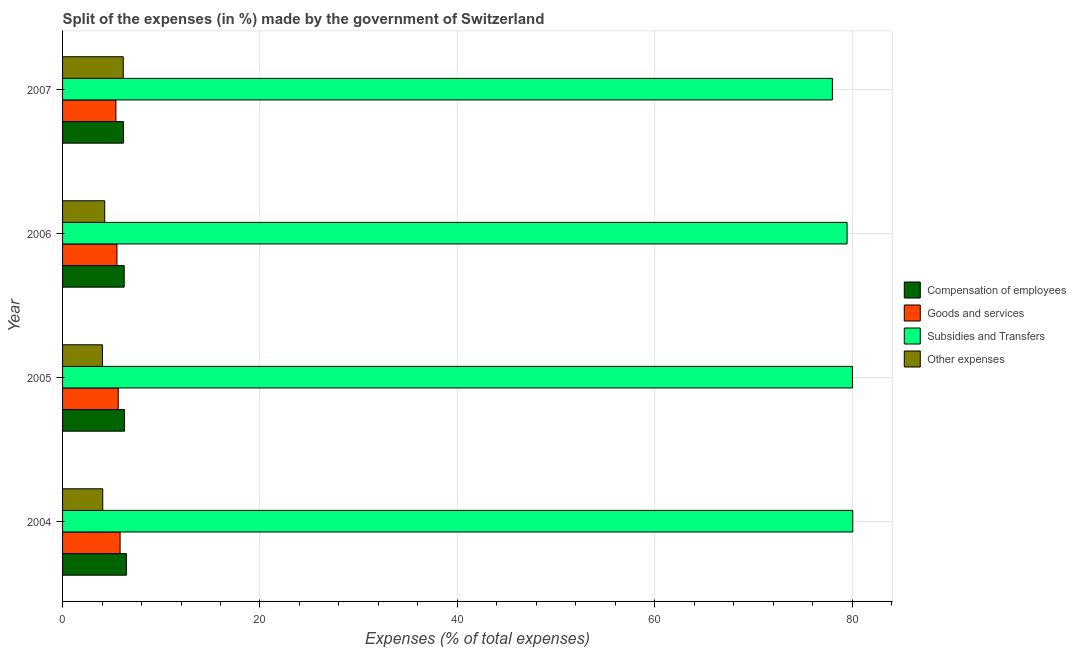How many different coloured bars are there?
Provide a succinct answer. 4. How many groups of bars are there?
Give a very brief answer. 4. Are the number of bars per tick equal to the number of legend labels?
Offer a terse response. Yes. Are the number of bars on each tick of the Y-axis equal?
Ensure brevity in your answer.  Yes. How many bars are there on the 3rd tick from the top?
Offer a terse response. 4. How many bars are there on the 2nd tick from the bottom?
Your answer should be compact. 4. What is the percentage of amount spent on subsidies in 2007?
Your response must be concise. 77.99. Across all years, what is the maximum percentage of amount spent on subsidies?
Ensure brevity in your answer.  80.05. Across all years, what is the minimum percentage of amount spent on subsidies?
Provide a short and direct response. 77.99. In which year was the percentage of amount spent on other expenses maximum?
Ensure brevity in your answer.  2007. What is the total percentage of amount spent on goods and services in the graph?
Make the answer very short. 22.38. What is the difference between the percentage of amount spent on compensation of employees in 2005 and that in 2006?
Your response must be concise. 0.03. What is the difference between the percentage of amount spent on goods and services in 2004 and the percentage of amount spent on compensation of employees in 2005?
Offer a very short reply. -0.45. What is the average percentage of amount spent on subsidies per year?
Your answer should be compact. 79.38. In the year 2006, what is the difference between the percentage of amount spent on compensation of employees and percentage of amount spent on subsidies?
Your answer should be very brief. -73.23. What is the ratio of the percentage of amount spent on goods and services in 2004 to that in 2005?
Your answer should be compact. 1.03. What is the difference between the highest and the second highest percentage of amount spent on goods and services?
Make the answer very short. 0.19. In how many years, is the percentage of amount spent on goods and services greater than the average percentage of amount spent on goods and services taken over all years?
Provide a succinct answer. 2. Is the sum of the percentage of amount spent on subsidies in 2004 and 2006 greater than the maximum percentage of amount spent on other expenses across all years?
Your answer should be compact. Yes. Is it the case that in every year, the sum of the percentage of amount spent on compensation of employees and percentage of amount spent on goods and services is greater than the sum of percentage of amount spent on other expenses and percentage of amount spent on subsidies?
Make the answer very short. No. What does the 3rd bar from the top in 2004 represents?
Give a very brief answer. Goods and services. What does the 3rd bar from the bottom in 2006 represents?
Your response must be concise. Subsidies and Transfers. Is it the case that in every year, the sum of the percentage of amount spent on compensation of employees and percentage of amount spent on goods and services is greater than the percentage of amount spent on subsidies?
Ensure brevity in your answer.  No. How many bars are there?
Keep it short and to the point. 16. Are all the bars in the graph horizontal?
Your response must be concise. Yes. What is the difference between two consecutive major ticks on the X-axis?
Offer a very short reply. 20. Are the values on the major ticks of X-axis written in scientific E-notation?
Ensure brevity in your answer.  No. What is the title of the graph?
Provide a succinct answer. Split of the expenses (in %) made by the government of Switzerland. Does "Denmark" appear as one of the legend labels in the graph?
Offer a very short reply. No. What is the label or title of the X-axis?
Offer a very short reply. Expenses (% of total expenses). What is the Expenses (% of total expenses) in Compensation of employees in 2004?
Offer a terse response. 6.47. What is the Expenses (% of total expenses) in Goods and services in 2004?
Provide a short and direct response. 5.83. What is the Expenses (% of total expenses) of Subsidies and Transfers in 2004?
Make the answer very short. 80.05. What is the Expenses (% of total expenses) in Other expenses in 2004?
Give a very brief answer. 4.07. What is the Expenses (% of total expenses) of Compensation of employees in 2005?
Your answer should be very brief. 6.28. What is the Expenses (% of total expenses) of Goods and services in 2005?
Ensure brevity in your answer.  5.64. What is the Expenses (% of total expenses) in Subsidies and Transfers in 2005?
Keep it short and to the point. 80.02. What is the Expenses (% of total expenses) in Other expenses in 2005?
Offer a terse response. 4.04. What is the Expenses (% of total expenses) in Compensation of employees in 2006?
Keep it short and to the point. 6.24. What is the Expenses (% of total expenses) in Goods and services in 2006?
Your answer should be very brief. 5.51. What is the Expenses (% of total expenses) in Subsidies and Transfers in 2006?
Your answer should be compact. 79.48. What is the Expenses (% of total expenses) in Other expenses in 2006?
Your response must be concise. 4.27. What is the Expenses (% of total expenses) of Compensation of employees in 2007?
Provide a short and direct response. 6.17. What is the Expenses (% of total expenses) of Goods and services in 2007?
Provide a short and direct response. 5.4. What is the Expenses (% of total expenses) of Subsidies and Transfers in 2007?
Provide a succinct answer. 77.99. What is the Expenses (% of total expenses) in Other expenses in 2007?
Offer a terse response. 6.15. Across all years, what is the maximum Expenses (% of total expenses) of Compensation of employees?
Provide a short and direct response. 6.47. Across all years, what is the maximum Expenses (% of total expenses) of Goods and services?
Your answer should be very brief. 5.83. Across all years, what is the maximum Expenses (% of total expenses) in Subsidies and Transfers?
Provide a succinct answer. 80.05. Across all years, what is the maximum Expenses (% of total expenses) of Other expenses?
Offer a very short reply. 6.15. Across all years, what is the minimum Expenses (% of total expenses) of Compensation of employees?
Give a very brief answer. 6.17. Across all years, what is the minimum Expenses (% of total expenses) in Goods and services?
Your answer should be compact. 5.4. Across all years, what is the minimum Expenses (% of total expenses) in Subsidies and Transfers?
Make the answer very short. 77.99. Across all years, what is the minimum Expenses (% of total expenses) of Other expenses?
Keep it short and to the point. 4.04. What is the total Expenses (% of total expenses) in Compensation of employees in the graph?
Give a very brief answer. 25.15. What is the total Expenses (% of total expenses) in Goods and services in the graph?
Provide a succinct answer. 22.38. What is the total Expenses (% of total expenses) of Subsidies and Transfers in the graph?
Your answer should be very brief. 317.53. What is the total Expenses (% of total expenses) in Other expenses in the graph?
Your response must be concise. 18.53. What is the difference between the Expenses (% of total expenses) of Compensation of employees in 2004 and that in 2005?
Your response must be concise. 0.19. What is the difference between the Expenses (% of total expenses) in Goods and services in 2004 and that in 2005?
Your answer should be very brief. 0.19. What is the difference between the Expenses (% of total expenses) of Subsidies and Transfers in 2004 and that in 2005?
Ensure brevity in your answer.  0.03. What is the difference between the Expenses (% of total expenses) in Other expenses in 2004 and that in 2005?
Your response must be concise. 0.03. What is the difference between the Expenses (% of total expenses) in Compensation of employees in 2004 and that in 2006?
Your response must be concise. 0.22. What is the difference between the Expenses (% of total expenses) of Goods and services in 2004 and that in 2006?
Provide a succinct answer. 0.32. What is the difference between the Expenses (% of total expenses) of Subsidies and Transfers in 2004 and that in 2006?
Keep it short and to the point. 0.57. What is the difference between the Expenses (% of total expenses) of Other expenses in 2004 and that in 2006?
Your response must be concise. -0.2. What is the difference between the Expenses (% of total expenses) in Compensation of employees in 2004 and that in 2007?
Ensure brevity in your answer.  0.3. What is the difference between the Expenses (% of total expenses) of Goods and services in 2004 and that in 2007?
Provide a succinct answer. 0.43. What is the difference between the Expenses (% of total expenses) of Subsidies and Transfers in 2004 and that in 2007?
Give a very brief answer. 2.06. What is the difference between the Expenses (% of total expenses) in Other expenses in 2004 and that in 2007?
Make the answer very short. -2.08. What is the difference between the Expenses (% of total expenses) of Compensation of employees in 2005 and that in 2006?
Keep it short and to the point. 0.03. What is the difference between the Expenses (% of total expenses) of Goods and services in 2005 and that in 2006?
Keep it short and to the point. 0.13. What is the difference between the Expenses (% of total expenses) in Subsidies and Transfers in 2005 and that in 2006?
Offer a very short reply. 0.54. What is the difference between the Expenses (% of total expenses) in Other expenses in 2005 and that in 2006?
Provide a short and direct response. -0.23. What is the difference between the Expenses (% of total expenses) of Compensation of employees in 2005 and that in 2007?
Offer a terse response. 0.11. What is the difference between the Expenses (% of total expenses) of Goods and services in 2005 and that in 2007?
Offer a terse response. 0.23. What is the difference between the Expenses (% of total expenses) in Subsidies and Transfers in 2005 and that in 2007?
Your answer should be compact. 2.03. What is the difference between the Expenses (% of total expenses) of Other expenses in 2005 and that in 2007?
Provide a short and direct response. -2.11. What is the difference between the Expenses (% of total expenses) in Compensation of employees in 2006 and that in 2007?
Your response must be concise. 0.08. What is the difference between the Expenses (% of total expenses) in Goods and services in 2006 and that in 2007?
Provide a succinct answer. 0.11. What is the difference between the Expenses (% of total expenses) in Subsidies and Transfers in 2006 and that in 2007?
Your response must be concise. 1.49. What is the difference between the Expenses (% of total expenses) in Other expenses in 2006 and that in 2007?
Provide a short and direct response. -1.88. What is the difference between the Expenses (% of total expenses) in Compensation of employees in 2004 and the Expenses (% of total expenses) in Goods and services in 2005?
Provide a short and direct response. 0.83. What is the difference between the Expenses (% of total expenses) in Compensation of employees in 2004 and the Expenses (% of total expenses) in Subsidies and Transfers in 2005?
Offer a very short reply. -73.55. What is the difference between the Expenses (% of total expenses) of Compensation of employees in 2004 and the Expenses (% of total expenses) of Other expenses in 2005?
Provide a short and direct response. 2.43. What is the difference between the Expenses (% of total expenses) of Goods and services in 2004 and the Expenses (% of total expenses) of Subsidies and Transfers in 2005?
Offer a terse response. -74.19. What is the difference between the Expenses (% of total expenses) in Goods and services in 2004 and the Expenses (% of total expenses) in Other expenses in 2005?
Your response must be concise. 1.79. What is the difference between the Expenses (% of total expenses) in Subsidies and Transfers in 2004 and the Expenses (% of total expenses) in Other expenses in 2005?
Your response must be concise. 76.01. What is the difference between the Expenses (% of total expenses) of Compensation of employees in 2004 and the Expenses (% of total expenses) of Goods and services in 2006?
Your answer should be very brief. 0.96. What is the difference between the Expenses (% of total expenses) in Compensation of employees in 2004 and the Expenses (% of total expenses) in Subsidies and Transfers in 2006?
Provide a succinct answer. -73.01. What is the difference between the Expenses (% of total expenses) of Compensation of employees in 2004 and the Expenses (% of total expenses) of Other expenses in 2006?
Provide a succinct answer. 2.2. What is the difference between the Expenses (% of total expenses) in Goods and services in 2004 and the Expenses (% of total expenses) in Subsidies and Transfers in 2006?
Keep it short and to the point. -73.65. What is the difference between the Expenses (% of total expenses) of Goods and services in 2004 and the Expenses (% of total expenses) of Other expenses in 2006?
Your response must be concise. 1.56. What is the difference between the Expenses (% of total expenses) in Subsidies and Transfers in 2004 and the Expenses (% of total expenses) in Other expenses in 2006?
Keep it short and to the point. 75.78. What is the difference between the Expenses (% of total expenses) of Compensation of employees in 2004 and the Expenses (% of total expenses) of Goods and services in 2007?
Provide a succinct answer. 1.06. What is the difference between the Expenses (% of total expenses) in Compensation of employees in 2004 and the Expenses (% of total expenses) in Subsidies and Transfers in 2007?
Provide a short and direct response. -71.52. What is the difference between the Expenses (% of total expenses) in Compensation of employees in 2004 and the Expenses (% of total expenses) in Other expenses in 2007?
Make the answer very short. 0.32. What is the difference between the Expenses (% of total expenses) of Goods and services in 2004 and the Expenses (% of total expenses) of Subsidies and Transfers in 2007?
Give a very brief answer. -72.16. What is the difference between the Expenses (% of total expenses) in Goods and services in 2004 and the Expenses (% of total expenses) in Other expenses in 2007?
Ensure brevity in your answer.  -0.32. What is the difference between the Expenses (% of total expenses) in Subsidies and Transfers in 2004 and the Expenses (% of total expenses) in Other expenses in 2007?
Ensure brevity in your answer.  73.9. What is the difference between the Expenses (% of total expenses) in Compensation of employees in 2005 and the Expenses (% of total expenses) in Goods and services in 2006?
Provide a short and direct response. 0.77. What is the difference between the Expenses (% of total expenses) of Compensation of employees in 2005 and the Expenses (% of total expenses) of Subsidies and Transfers in 2006?
Make the answer very short. -73.2. What is the difference between the Expenses (% of total expenses) of Compensation of employees in 2005 and the Expenses (% of total expenses) of Other expenses in 2006?
Give a very brief answer. 2.01. What is the difference between the Expenses (% of total expenses) in Goods and services in 2005 and the Expenses (% of total expenses) in Subsidies and Transfers in 2006?
Your answer should be very brief. -73.84. What is the difference between the Expenses (% of total expenses) in Goods and services in 2005 and the Expenses (% of total expenses) in Other expenses in 2006?
Provide a succinct answer. 1.37. What is the difference between the Expenses (% of total expenses) in Subsidies and Transfers in 2005 and the Expenses (% of total expenses) in Other expenses in 2006?
Provide a succinct answer. 75.75. What is the difference between the Expenses (% of total expenses) of Compensation of employees in 2005 and the Expenses (% of total expenses) of Subsidies and Transfers in 2007?
Offer a very short reply. -71.71. What is the difference between the Expenses (% of total expenses) of Compensation of employees in 2005 and the Expenses (% of total expenses) of Other expenses in 2007?
Offer a terse response. 0.13. What is the difference between the Expenses (% of total expenses) in Goods and services in 2005 and the Expenses (% of total expenses) in Subsidies and Transfers in 2007?
Give a very brief answer. -72.35. What is the difference between the Expenses (% of total expenses) of Goods and services in 2005 and the Expenses (% of total expenses) of Other expenses in 2007?
Ensure brevity in your answer.  -0.51. What is the difference between the Expenses (% of total expenses) in Subsidies and Transfers in 2005 and the Expenses (% of total expenses) in Other expenses in 2007?
Your response must be concise. 73.87. What is the difference between the Expenses (% of total expenses) in Compensation of employees in 2006 and the Expenses (% of total expenses) in Goods and services in 2007?
Offer a terse response. 0.84. What is the difference between the Expenses (% of total expenses) of Compensation of employees in 2006 and the Expenses (% of total expenses) of Subsidies and Transfers in 2007?
Provide a succinct answer. -71.74. What is the difference between the Expenses (% of total expenses) of Compensation of employees in 2006 and the Expenses (% of total expenses) of Other expenses in 2007?
Offer a terse response. 0.1. What is the difference between the Expenses (% of total expenses) in Goods and services in 2006 and the Expenses (% of total expenses) in Subsidies and Transfers in 2007?
Your answer should be very brief. -72.48. What is the difference between the Expenses (% of total expenses) in Goods and services in 2006 and the Expenses (% of total expenses) in Other expenses in 2007?
Offer a terse response. -0.64. What is the difference between the Expenses (% of total expenses) of Subsidies and Transfers in 2006 and the Expenses (% of total expenses) of Other expenses in 2007?
Provide a succinct answer. 73.33. What is the average Expenses (% of total expenses) in Compensation of employees per year?
Offer a very short reply. 6.29. What is the average Expenses (% of total expenses) in Goods and services per year?
Provide a succinct answer. 5.59. What is the average Expenses (% of total expenses) of Subsidies and Transfers per year?
Offer a very short reply. 79.38. What is the average Expenses (% of total expenses) of Other expenses per year?
Offer a very short reply. 4.63. In the year 2004, what is the difference between the Expenses (% of total expenses) in Compensation of employees and Expenses (% of total expenses) in Goods and services?
Offer a very short reply. 0.64. In the year 2004, what is the difference between the Expenses (% of total expenses) of Compensation of employees and Expenses (% of total expenses) of Subsidies and Transfers?
Offer a terse response. -73.58. In the year 2004, what is the difference between the Expenses (% of total expenses) of Compensation of employees and Expenses (% of total expenses) of Other expenses?
Your answer should be very brief. 2.39. In the year 2004, what is the difference between the Expenses (% of total expenses) in Goods and services and Expenses (% of total expenses) in Subsidies and Transfers?
Your response must be concise. -74.22. In the year 2004, what is the difference between the Expenses (% of total expenses) of Goods and services and Expenses (% of total expenses) of Other expenses?
Your response must be concise. 1.76. In the year 2004, what is the difference between the Expenses (% of total expenses) in Subsidies and Transfers and Expenses (% of total expenses) in Other expenses?
Your answer should be very brief. 75.98. In the year 2005, what is the difference between the Expenses (% of total expenses) in Compensation of employees and Expenses (% of total expenses) in Goods and services?
Make the answer very short. 0.64. In the year 2005, what is the difference between the Expenses (% of total expenses) of Compensation of employees and Expenses (% of total expenses) of Subsidies and Transfers?
Offer a terse response. -73.74. In the year 2005, what is the difference between the Expenses (% of total expenses) in Compensation of employees and Expenses (% of total expenses) in Other expenses?
Ensure brevity in your answer.  2.24. In the year 2005, what is the difference between the Expenses (% of total expenses) in Goods and services and Expenses (% of total expenses) in Subsidies and Transfers?
Your response must be concise. -74.38. In the year 2005, what is the difference between the Expenses (% of total expenses) of Goods and services and Expenses (% of total expenses) of Other expenses?
Give a very brief answer. 1.6. In the year 2005, what is the difference between the Expenses (% of total expenses) of Subsidies and Transfers and Expenses (% of total expenses) of Other expenses?
Offer a terse response. 75.98. In the year 2006, what is the difference between the Expenses (% of total expenses) in Compensation of employees and Expenses (% of total expenses) in Goods and services?
Your response must be concise. 0.74. In the year 2006, what is the difference between the Expenses (% of total expenses) of Compensation of employees and Expenses (% of total expenses) of Subsidies and Transfers?
Provide a short and direct response. -73.23. In the year 2006, what is the difference between the Expenses (% of total expenses) in Compensation of employees and Expenses (% of total expenses) in Other expenses?
Keep it short and to the point. 1.97. In the year 2006, what is the difference between the Expenses (% of total expenses) of Goods and services and Expenses (% of total expenses) of Subsidies and Transfers?
Your response must be concise. -73.97. In the year 2006, what is the difference between the Expenses (% of total expenses) of Goods and services and Expenses (% of total expenses) of Other expenses?
Provide a short and direct response. 1.24. In the year 2006, what is the difference between the Expenses (% of total expenses) in Subsidies and Transfers and Expenses (% of total expenses) in Other expenses?
Your answer should be compact. 75.21. In the year 2007, what is the difference between the Expenses (% of total expenses) in Compensation of employees and Expenses (% of total expenses) in Goods and services?
Ensure brevity in your answer.  0.76. In the year 2007, what is the difference between the Expenses (% of total expenses) of Compensation of employees and Expenses (% of total expenses) of Subsidies and Transfers?
Keep it short and to the point. -71.82. In the year 2007, what is the difference between the Expenses (% of total expenses) in Compensation of employees and Expenses (% of total expenses) in Other expenses?
Ensure brevity in your answer.  0.02. In the year 2007, what is the difference between the Expenses (% of total expenses) of Goods and services and Expenses (% of total expenses) of Subsidies and Transfers?
Your response must be concise. -72.58. In the year 2007, what is the difference between the Expenses (% of total expenses) in Goods and services and Expenses (% of total expenses) in Other expenses?
Your answer should be very brief. -0.74. In the year 2007, what is the difference between the Expenses (% of total expenses) in Subsidies and Transfers and Expenses (% of total expenses) in Other expenses?
Make the answer very short. 71.84. What is the ratio of the Expenses (% of total expenses) in Compensation of employees in 2004 to that in 2005?
Give a very brief answer. 1.03. What is the ratio of the Expenses (% of total expenses) in Goods and services in 2004 to that in 2005?
Provide a short and direct response. 1.03. What is the ratio of the Expenses (% of total expenses) of Other expenses in 2004 to that in 2005?
Provide a succinct answer. 1.01. What is the ratio of the Expenses (% of total expenses) of Compensation of employees in 2004 to that in 2006?
Your response must be concise. 1.04. What is the ratio of the Expenses (% of total expenses) in Goods and services in 2004 to that in 2006?
Your answer should be very brief. 1.06. What is the ratio of the Expenses (% of total expenses) in Subsidies and Transfers in 2004 to that in 2006?
Keep it short and to the point. 1.01. What is the ratio of the Expenses (% of total expenses) in Other expenses in 2004 to that in 2006?
Offer a terse response. 0.95. What is the ratio of the Expenses (% of total expenses) in Compensation of employees in 2004 to that in 2007?
Your answer should be very brief. 1.05. What is the ratio of the Expenses (% of total expenses) of Goods and services in 2004 to that in 2007?
Offer a very short reply. 1.08. What is the ratio of the Expenses (% of total expenses) in Subsidies and Transfers in 2004 to that in 2007?
Give a very brief answer. 1.03. What is the ratio of the Expenses (% of total expenses) in Other expenses in 2004 to that in 2007?
Your response must be concise. 0.66. What is the ratio of the Expenses (% of total expenses) of Compensation of employees in 2005 to that in 2006?
Make the answer very short. 1.01. What is the ratio of the Expenses (% of total expenses) of Goods and services in 2005 to that in 2006?
Ensure brevity in your answer.  1.02. What is the ratio of the Expenses (% of total expenses) in Subsidies and Transfers in 2005 to that in 2006?
Your answer should be very brief. 1.01. What is the ratio of the Expenses (% of total expenses) of Other expenses in 2005 to that in 2006?
Offer a very short reply. 0.95. What is the ratio of the Expenses (% of total expenses) in Compensation of employees in 2005 to that in 2007?
Keep it short and to the point. 1.02. What is the ratio of the Expenses (% of total expenses) in Goods and services in 2005 to that in 2007?
Keep it short and to the point. 1.04. What is the ratio of the Expenses (% of total expenses) in Subsidies and Transfers in 2005 to that in 2007?
Provide a short and direct response. 1.03. What is the ratio of the Expenses (% of total expenses) in Other expenses in 2005 to that in 2007?
Your answer should be compact. 0.66. What is the ratio of the Expenses (% of total expenses) in Compensation of employees in 2006 to that in 2007?
Keep it short and to the point. 1.01. What is the ratio of the Expenses (% of total expenses) of Goods and services in 2006 to that in 2007?
Your answer should be compact. 1.02. What is the ratio of the Expenses (% of total expenses) in Subsidies and Transfers in 2006 to that in 2007?
Provide a succinct answer. 1.02. What is the ratio of the Expenses (% of total expenses) in Other expenses in 2006 to that in 2007?
Offer a terse response. 0.69. What is the difference between the highest and the second highest Expenses (% of total expenses) of Compensation of employees?
Offer a terse response. 0.19. What is the difference between the highest and the second highest Expenses (% of total expenses) in Goods and services?
Offer a very short reply. 0.19. What is the difference between the highest and the second highest Expenses (% of total expenses) in Subsidies and Transfers?
Your answer should be compact. 0.03. What is the difference between the highest and the second highest Expenses (% of total expenses) of Other expenses?
Your answer should be compact. 1.88. What is the difference between the highest and the lowest Expenses (% of total expenses) in Compensation of employees?
Provide a succinct answer. 0.3. What is the difference between the highest and the lowest Expenses (% of total expenses) of Goods and services?
Offer a terse response. 0.43. What is the difference between the highest and the lowest Expenses (% of total expenses) in Subsidies and Transfers?
Provide a short and direct response. 2.06. What is the difference between the highest and the lowest Expenses (% of total expenses) in Other expenses?
Offer a terse response. 2.11. 